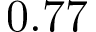Convert formula to latex. <formula><loc_0><loc_0><loc_500><loc_500>0 . 7 7</formula> 